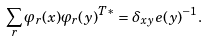<formula> <loc_0><loc_0><loc_500><loc_500>\sum _ { r } \varphi _ { r } ( x ) \varphi _ { r } ( y ) ^ { T * } = \delta _ { x y } e ( y ) ^ { - 1 } .</formula> 